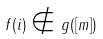Convert formula to latex. <formula><loc_0><loc_0><loc_500><loc_500>f ( i ) \notin g ( [ m ] )</formula> 